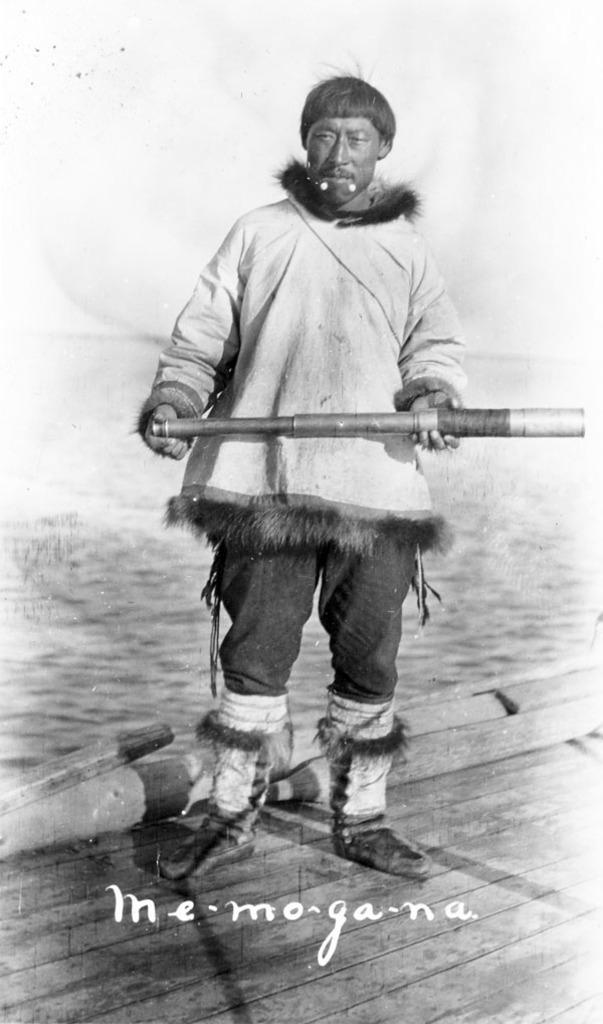What is the main subject of the image? There is a person in the image. What is the person standing on? The person is standing on a wooden surface. What is the person holding in the image? The person is holding a rod. What color is the background of the image? The background of the image is white. How much money is the person holding in the image? There is no money visible in the image; the person is holding a rod. What type of playground equipment can be seen in the image? There is no playground equipment present in the image. 